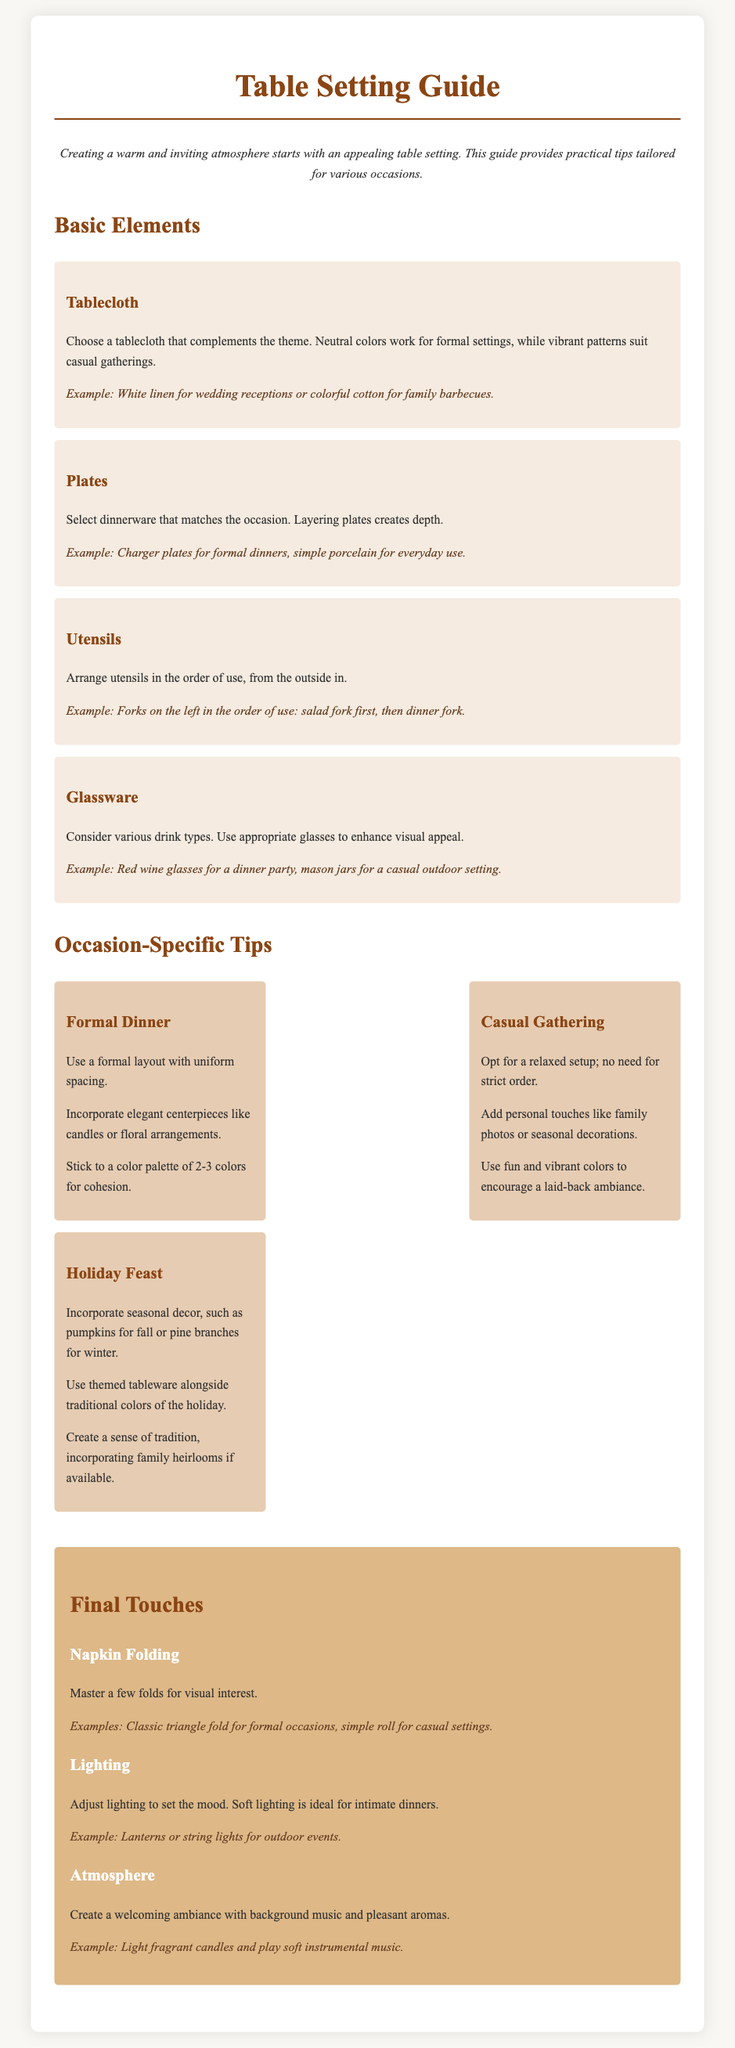what color tablecloth is recommended for formal settings? A neutral color tablecloth is suggested for formal settings to complement the theme.
Answer: Neutral colors what is one example of dinnerware for formal dinners? The document provides charger plates as an example of dinnerware suited for formal dinners.
Answer: Charger plates how should utensils be arranged on the table? Utensils should be arranged in the order of use, from the outside in.
Answer: Outside in what types of glasses should be used for a dinner party? The guide recommends using red wine glasses for a dinner party setting.
Answer: Red wine glasses what is a key aspect of a formal dinner layout? The layout for a formal dinner should feature uniform spacing between the items.
Answer: Uniform spacing how can personal touches be added to a casual gathering? Adding family photos or seasonal decorations provides personal touches to a casual gathering.
Answer: Family photos or seasonal decorations what should be adjusted to set the mood for a dinner? Adjusting the lighting is crucial to setting the mood for a dinner.
Answer: Lighting what is one example of seasonal decor for winter? The document suggests using pine branches as a seasonal decor for winter.
Answer: Pine branches what is an example of a napkin fold for a formal occasion? The classic triangle fold is an example of a napkin fold suitable for formal occasions.
Answer: Classic triangle fold 